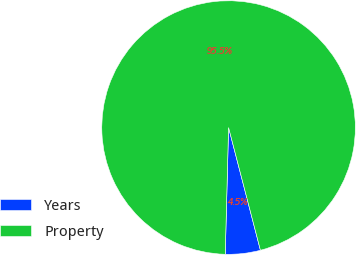Convert chart to OTSL. <chart><loc_0><loc_0><loc_500><loc_500><pie_chart><fcel>Years<fcel>Property<nl><fcel>4.46%<fcel>95.54%<nl></chart> 